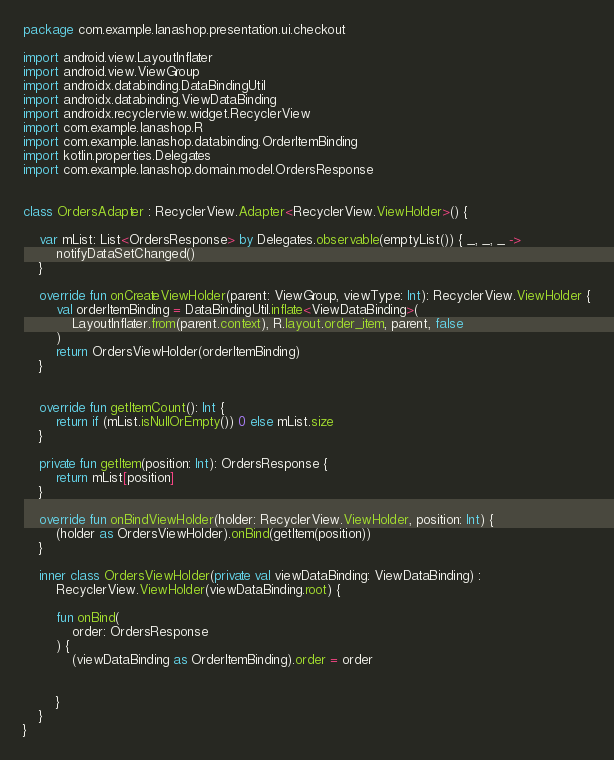<code> <loc_0><loc_0><loc_500><loc_500><_Kotlin_>package com.example.lanashop.presentation.ui.checkout

import android.view.LayoutInflater
import android.view.ViewGroup
import androidx.databinding.DataBindingUtil
import androidx.databinding.ViewDataBinding
import androidx.recyclerview.widget.RecyclerView
import com.example.lanashop.R
import com.example.lanashop.databinding.OrderItemBinding
import kotlin.properties.Delegates
import com.example.lanashop.domain.model.OrdersResponse


class OrdersAdapter : RecyclerView.Adapter<RecyclerView.ViewHolder>() {

    var mList: List<OrdersResponse> by Delegates.observable(emptyList()) { _, _, _ ->
        notifyDataSetChanged()
    }

    override fun onCreateViewHolder(parent: ViewGroup, viewType: Int): RecyclerView.ViewHolder {
        val orderItemBinding = DataBindingUtil.inflate<ViewDataBinding>(
            LayoutInflater.from(parent.context), R.layout.order_item, parent, false
        )
        return OrdersViewHolder(orderItemBinding)
    }


    override fun getItemCount(): Int {
        return if (mList.isNullOrEmpty()) 0 else mList.size
    }

    private fun getItem(position: Int): OrdersResponse {
        return mList[position]
    }

    override fun onBindViewHolder(holder: RecyclerView.ViewHolder, position: Int) {
        (holder as OrdersViewHolder).onBind(getItem(position))
    }

    inner class OrdersViewHolder(private val viewDataBinding: ViewDataBinding) :
        RecyclerView.ViewHolder(viewDataBinding.root) {

        fun onBind(
            order: OrdersResponse
        ) {
            (viewDataBinding as OrderItemBinding).order = order


        }
    }
}</code> 